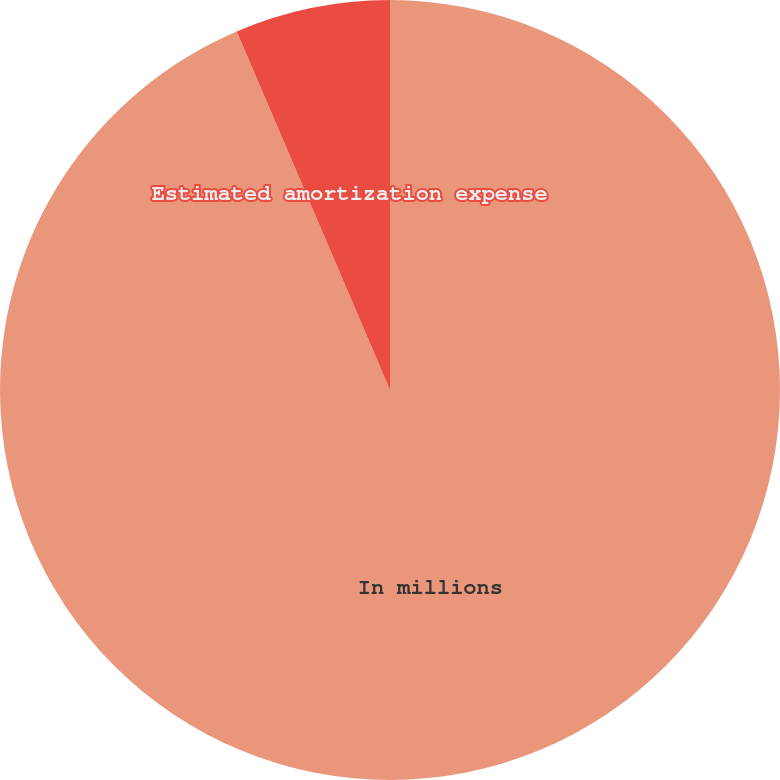<chart> <loc_0><loc_0><loc_500><loc_500><pie_chart><fcel>In millions<fcel>Estimated amortization expense<nl><fcel>93.57%<fcel>6.43%<nl></chart> 